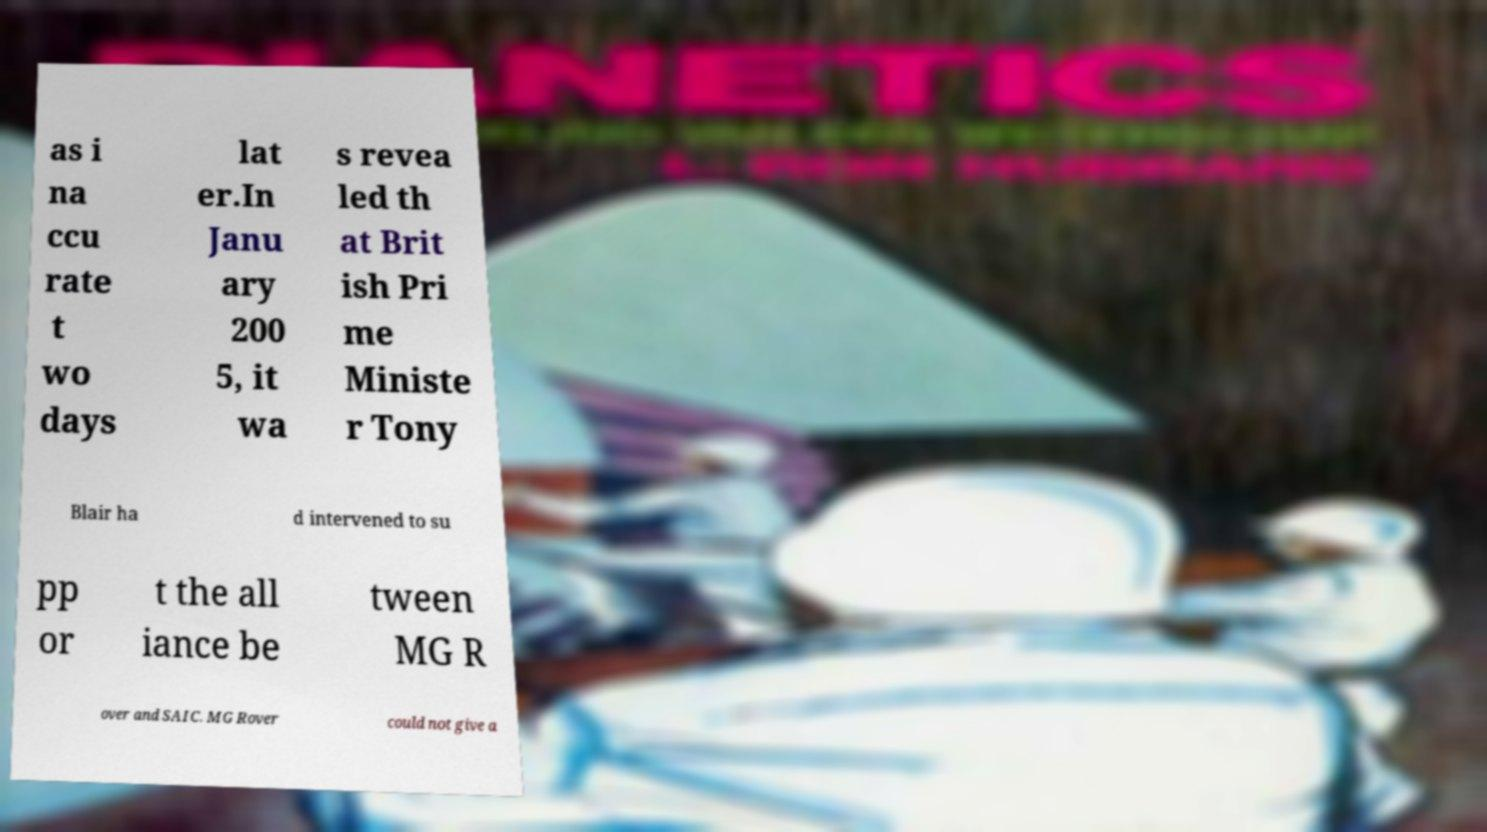I need the written content from this picture converted into text. Can you do that? as i na ccu rate t wo days lat er.In Janu ary 200 5, it wa s revea led th at Brit ish Pri me Ministe r Tony Blair ha d intervened to su pp or t the all iance be tween MG R over and SAIC. MG Rover could not give a 